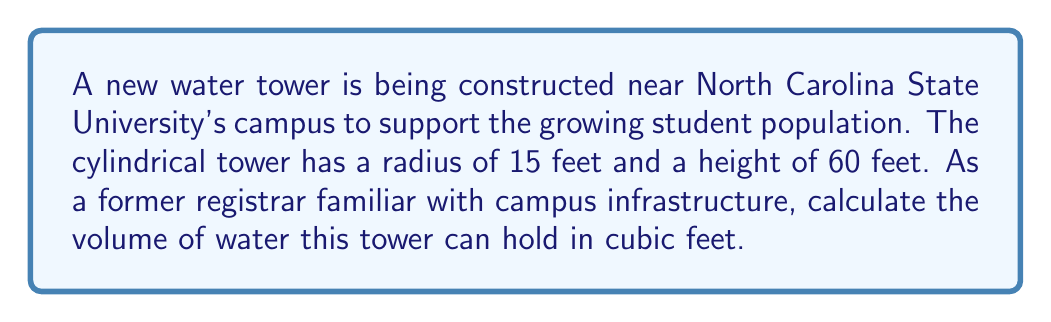Help me with this question. To solve this problem, we'll use the formula for the volume of a cylinder:

$$V = \pi r^2 h$$

Where:
$V$ = volume
$r$ = radius of the base
$h$ = height of the cylinder

Given:
$r = 15$ feet
$h = 60$ feet

Let's substitute these values into our formula:

$$\begin{align*}
V &= \pi r^2 h \\
&= \pi (15\text{ ft})^2 (60\text{ ft}) \\
&= \pi (225\text{ ft}^2) (60\text{ ft}) \\
&= 13,500\pi \text{ ft}^3
\end{align*}$$

Now, let's calculate this value:

$$13,500\pi \approx 42,411.50 \text{ ft}^3$$

We can round this to the nearest cubic foot:

$$V \approx 42,412 \text{ ft}^3$$

[asy]
import geometry;

size(200);
real r = 15;
real h = 60;
real scale = 2;

path base = scale(scale)*circle((0,0),r);
path top = scale(scale)*circle((0,h),r);

draw(base);
draw(top);
draw(scale(scale)*((r,0)--(r,h)));
draw(scale(scale)*((-r,0)--(-r,h)));

label("r = 15 ft", scale(scale)*(r/2,-5), E);
label("h = 60 ft", scale(scale)*(r+2,h/2), E);

[/asy]
Answer: The water tower can hold approximately 42,412 cubic feet of water. 